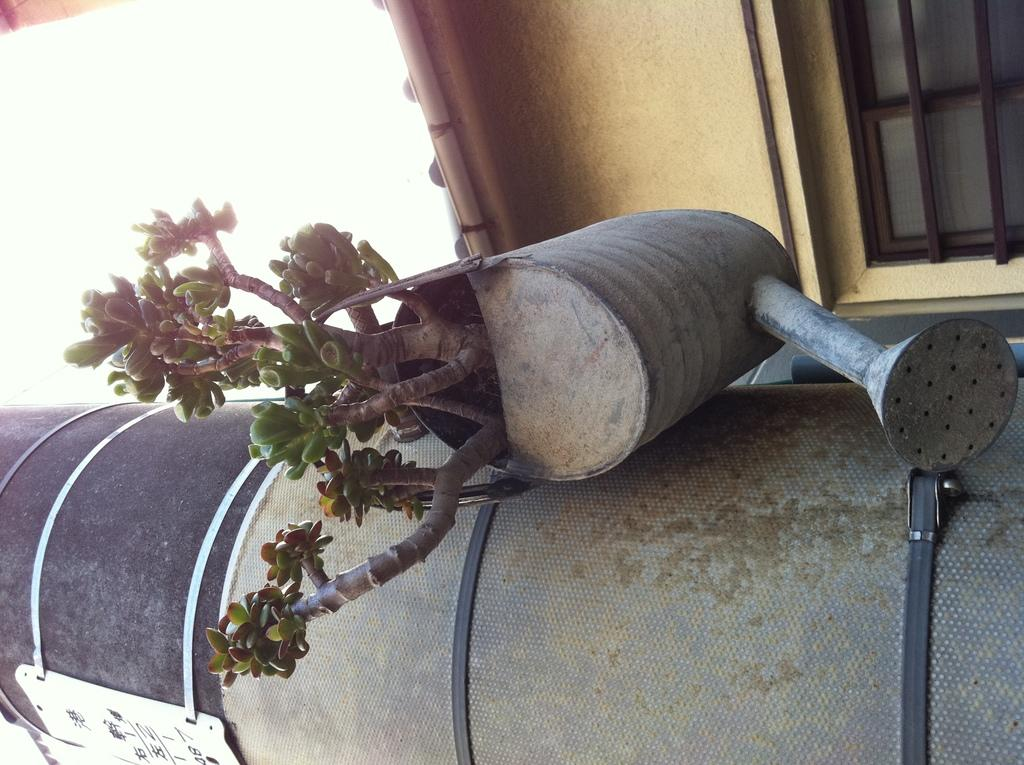What is the main object in the image? There is a pillar in the image. What is placed on the pillar? A watering can is present on the pillar. What is inside the watering can? There is a plant in the watering can. What can be seen in the background of the image? There are windows, a house, and the sky visible in the background of the image. What type of prose can be seen written on the pillar in the image? There is no prose or writing present on the pillar in the image. How does the ice interact with the plant in the watering can? There is no ice present in the image; it only features a plant in a watering can on a pillar. 